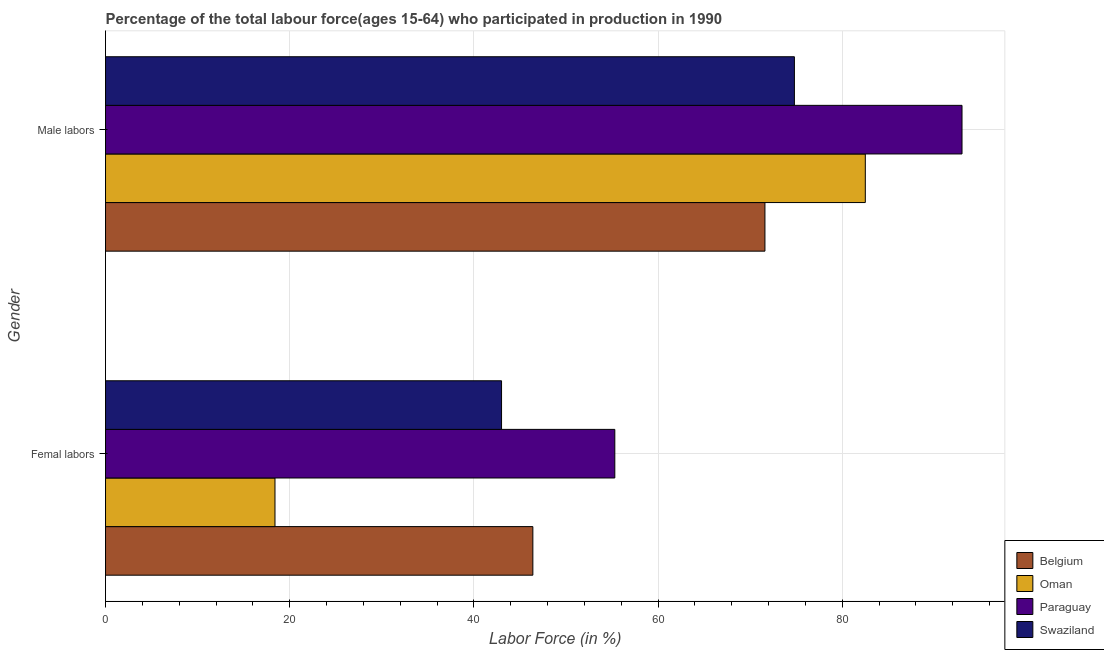How many bars are there on the 1st tick from the top?
Your response must be concise. 4. How many bars are there on the 2nd tick from the bottom?
Offer a terse response. 4. What is the label of the 1st group of bars from the top?
Your answer should be compact. Male labors. What is the percentage of female labor force in Oman?
Provide a short and direct response. 18.4. Across all countries, what is the maximum percentage of male labour force?
Provide a short and direct response. 93. Across all countries, what is the minimum percentage of male labour force?
Keep it short and to the point. 71.6. In which country was the percentage of male labour force maximum?
Ensure brevity in your answer.  Paraguay. In which country was the percentage of female labor force minimum?
Provide a succinct answer. Oman. What is the total percentage of male labour force in the graph?
Your answer should be very brief. 321.9. What is the difference between the percentage of male labour force in Belgium and that in Paraguay?
Give a very brief answer. -21.4. What is the difference between the percentage of female labor force in Paraguay and the percentage of male labour force in Belgium?
Your response must be concise. -16.3. What is the average percentage of female labor force per country?
Ensure brevity in your answer.  40.78. What is the difference between the percentage of male labour force and percentage of female labor force in Belgium?
Provide a succinct answer. 25.2. In how many countries, is the percentage of male labour force greater than 80 %?
Provide a short and direct response. 2. What is the ratio of the percentage of male labour force in Oman to that in Swaziland?
Offer a terse response. 1.1. In how many countries, is the percentage of female labor force greater than the average percentage of female labor force taken over all countries?
Make the answer very short. 3. What does the 2nd bar from the top in Male labors represents?
Keep it short and to the point. Paraguay. What does the 2nd bar from the bottom in Male labors represents?
Provide a short and direct response. Oman. What is the difference between two consecutive major ticks on the X-axis?
Offer a very short reply. 20. Are the values on the major ticks of X-axis written in scientific E-notation?
Give a very brief answer. No. Does the graph contain grids?
Provide a succinct answer. Yes. How many legend labels are there?
Your answer should be very brief. 4. What is the title of the graph?
Give a very brief answer. Percentage of the total labour force(ages 15-64) who participated in production in 1990. What is the label or title of the Y-axis?
Provide a succinct answer. Gender. What is the Labor Force (in %) of Belgium in Femal labors?
Your answer should be very brief. 46.4. What is the Labor Force (in %) of Oman in Femal labors?
Offer a terse response. 18.4. What is the Labor Force (in %) of Paraguay in Femal labors?
Your response must be concise. 55.3. What is the Labor Force (in %) of Belgium in Male labors?
Provide a short and direct response. 71.6. What is the Labor Force (in %) of Oman in Male labors?
Provide a succinct answer. 82.5. What is the Labor Force (in %) in Paraguay in Male labors?
Ensure brevity in your answer.  93. What is the Labor Force (in %) in Swaziland in Male labors?
Keep it short and to the point. 74.8. Across all Gender, what is the maximum Labor Force (in %) of Belgium?
Provide a short and direct response. 71.6. Across all Gender, what is the maximum Labor Force (in %) of Oman?
Ensure brevity in your answer.  82.5. Across all Gender, what is the maximum Labor Force (in %) of Paraguay?
Give a very brief answer. 93. Across all Gender, what is the maximum Labor Force (in %) of Swaziland?
Offer a very short reply. 74.8. Across all Gender, what is the minimum Labor Force (in %) of Belgium?
Your response must be concise. 46.4. Across all Gender, what is the minimum Labor Force (in %) of Oman?
Provide a succinct answer. 18.4. Across all Gender, what is the minimum Labor Force (in %) of Paraguay?
Ensure brevity in your answer.  55.3. What is the total Labor Force (in %) of Belgium in the graph?
Provide a short and direct response. 118. What is the total Labor Force (in %) in Oman in the graph?
Your response must be concise. 100.9. What is the total Labor Force (in %) of Paraguay in the graph?
Your response must be concise. 148.3. What is the total Labor Force (in %) of Swaziland in the graph?
Provide a succinct answer. 117.8. What is the difference between the Labor Force (in %) of Belgium in Femal labors and that in Male labors?
Give a very brief answer. -25.2. What is the difference between the Labor Force (in %) in Oman in Femal labors and that in Male labors?
Offer a very short reply. -64.1. What is the difference between the Labor Force (in %) in Paraguay in Femal labors and that in Male labors?
Your response must be concise. -37.7. What is the difference between the Labor Force (in %) in Swaziland in Femal labors and that in Male labors?
Offer a very short reply. -31.8. What is the difference between the Labor Force (in %) of Belgium in Femal labors and the Labor Force (in %) of Oman in Male labors?
Your answer should be compact. -36.1. What is the difference between the Labor Force (in %) of Belgium in Femal labors and the Labor Force (in %) of Paraguay in Male labors?
Offer a terse response. -46.6. What is the difference between the Labor Force (in %) in Belgium in Femal labors and the Labor Force (in %) in Swaziland in Male labors?
Make the answer very short. -28.4. What is the difference between the Labor Force (in %) in Oman in Femal labors and the Labor Force (in %) in Paraguay in Male labors?
Make the answer very short. -74.6. What is the difference between the Labor Force (in %) in Oman in Femal labors and the Labor Force (in %) in Swaziland in Male labors?
Give a very brief answer. -56.4. What is the difference between the Labor Force (in %) in Paraguay in Femal labors and the Labor Force (in %) in Swaziland in Male labors?
Offer a very short reply. -19.5. What is the average Labor Force (in %) in Belgium per Gender?
Your response must be concise. 59. What is the average Labor Force (in %) in Oman per Gender?
Provide a succinct answer. 50.45. What is the average Labor Force (in %) in Paraguay per Gender?
Keep it short and to the point. 74.15. What is the average Labor Force (in %) of Swaziland per Gender?
Provide a short and direct response. 58.9. What is the difference between the Labor Force (in %) in Belgium and Labor Force (in %) in Oman in Femal labors?
Offer a very short reply. 28. What is the difference between the Labor Force (in %) in Oman and Labor Force (in %) in Paraguay in Femal labors?
Your answer should be very brief. -36.9. What is the difference between the Labor Force (in %) in Oman and Labor Force (in %) in Swaziland in Femal labors?
Your response must be concise. -24.6. What is the difference between the Labor Force (in %) of Belgium and Labor Force (in %) of Paraguay in Male labors?
Provide a succinct answer. -21.4. What is the difference between the Labor Force (in %) of Oman and Labor Force (in %) of Paraguay in Male labors?
Provide a succinct answer. -10.5. What is the difference between the Labor Force (in %) in Oman and Labor Force (in %) in Swaziland in Male labors?
Provide a succinct answer. 7.7. What is the difference between the Labor Force (in %) of Paraguay and Labor Force (in %) of Swaziland in Male labors?
Your response must be concise. 18.2. What is the ratio of the Labor Force (in %) of Belgium in Femal labors to that in Male labors?
Ensure brevity in your answer.  0.65. What is the ratio of the Labor Force (in %) of Oman in Femal labors to that in Male labors?
Provide a short and direct response. 0.22. What is the ratio of the Labor Force (in %) of Paraguay in Femal labors to that in Male labors?
Make the answer very short. 0.59. What is the ratio of the Labor Force (in %) of Swaziland in Femal labors to that in Male labors?
Provide a succinct answer. 0.57. What is the difference between the highest and the second highest Labor Force (in %) of Belgium?
Give a very brief answer. 25.2. What is the difference between the highest and the second highest Labor Force (in %) of Oman?
Keep it short and to the point. 64.1. What is the difference between the highest and the second highest Labor Force (in %) of Paraguay?
Keep it short and to the point. 37.7. What is the difference between the highest and the second highest Labor Force (in %) in Swaziland?
Ensure brevity in your answer.  31.8. What is the difference between the highest and the lowest Labor Force (in %) of Belgium?
Give a very brief answer. 25.2. What is the difference between the highest and the lowest Labor Force (in %) of Oman?
Offer a very short reply. 64.1. What is the difference between the highest and the lowest Labor Force (in %) of Paraguay?
Offer a terse response. 37.7. What is the difference between the highest and the lowest Labor Force (in %) in Swaziland?
Ensure brevity in your answer.  31.8. 